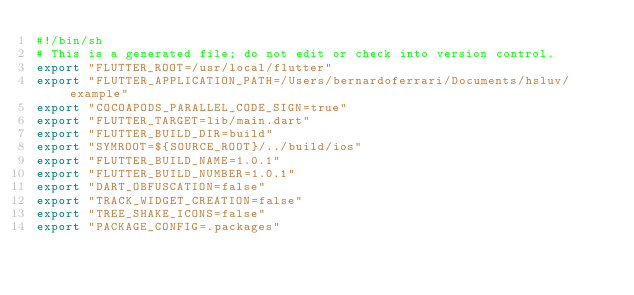<code> <loc_0><loc_0><loc_500><loc_500><_Bash_>#!/bin/sh
# This is a generated file; do not edit or check into version control.
export "FLUTTER_ROOT=/usr/local/flutter"
export "FLUTTER_APPLICATION_PATH=/Users/bernardoferrari/Documents/hsluv/example"
export "COCOAPODS_PARALLEL_CODE_SIGN=true"
export "FLUTTER_TARGET=lib/main.dart"
export "FLUTTER_BUILD_DIR=build"
export "SYMROOT=${SOURCE_ROOT}/../build/ios"
export "FLUTTER_BUILD_NAME=1.0.1"
export "FLUTTER_BUILD_NUMBER=1.0.1"
export "DART_OBFUSCATION=false"
export "TRACK_WIDGET_CREATION=false"
export "TREE_SHAKE_ICONS=false"
export "PACKAGE_CONFIG=.packages"
</code> 